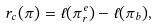Convert formula to latex. <formula><loc_0><loc_0><loc_500><loc_500>r _ { c } ( \pi ) = \ell ( \pi _ { r } ^ { e } ) - \ell ( \pi _ { b } ) ,</formula> 